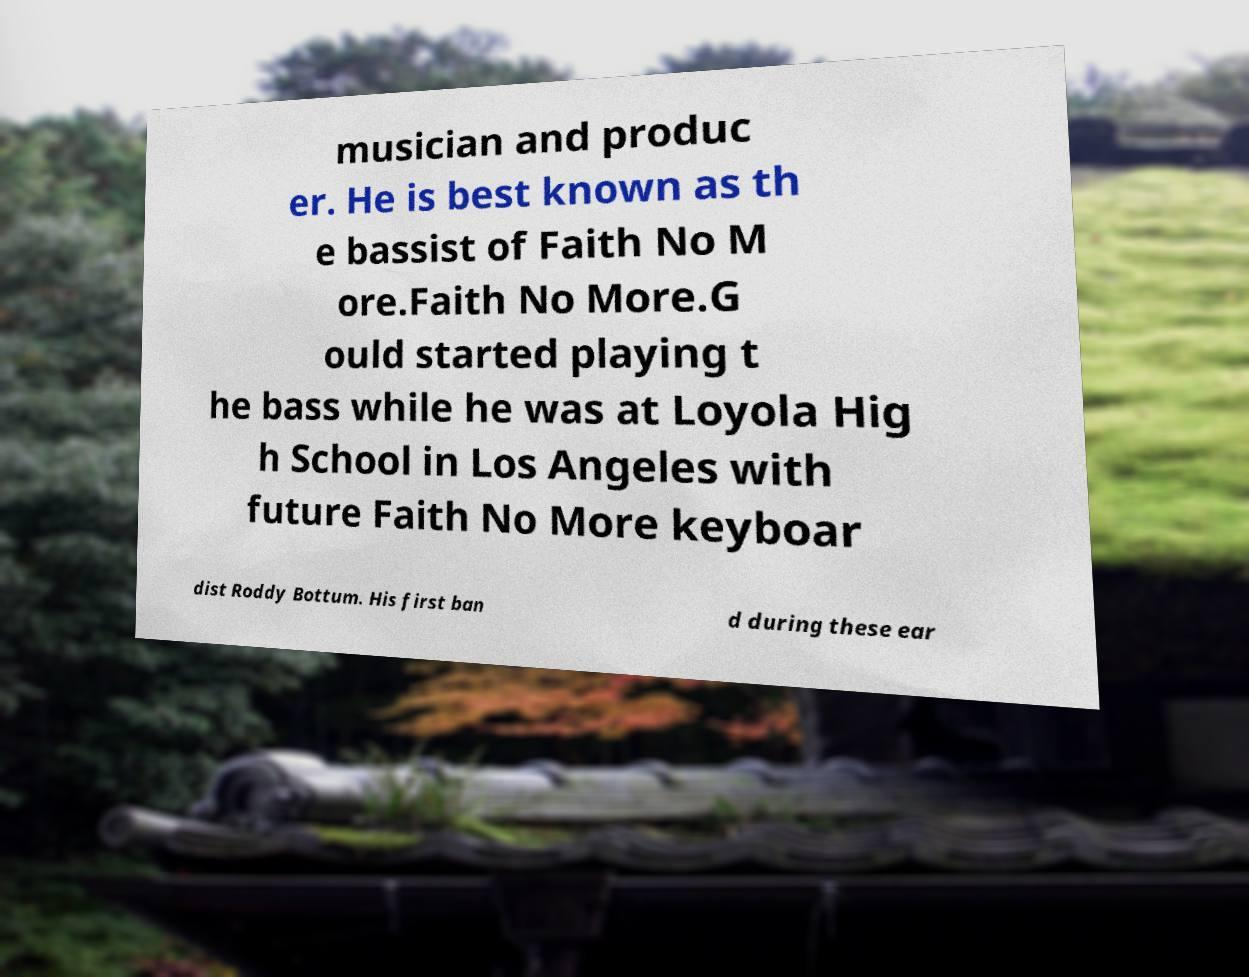For documentation purposes, I need the text within this image transcribed. Could you provide that? musician and produc er. He is best known as th e bassist of Faith No M ore.Faith No More.G ould started playing t he bass while he was at Loyola Hig h School in Los Angeles with future Faith No More keyboar dist Roddy Bottum. His first ban d during these ear 